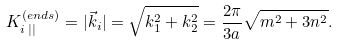Convert formula to latex. <formula><loc_0><loc_0><loc_500><loc_500>K _ { i \, | | } ^ { ( e n d s ) } = | \vec { k } _ { i } | = \sqrt { k _ { 1 } ^ { 2 } + k _ { 2 } ^ { 2 } } = \frac { 2 \pi } { 3 a } \sqrt { m ^ { 2 } + 3 n ^ { 2 } } .</formula> 